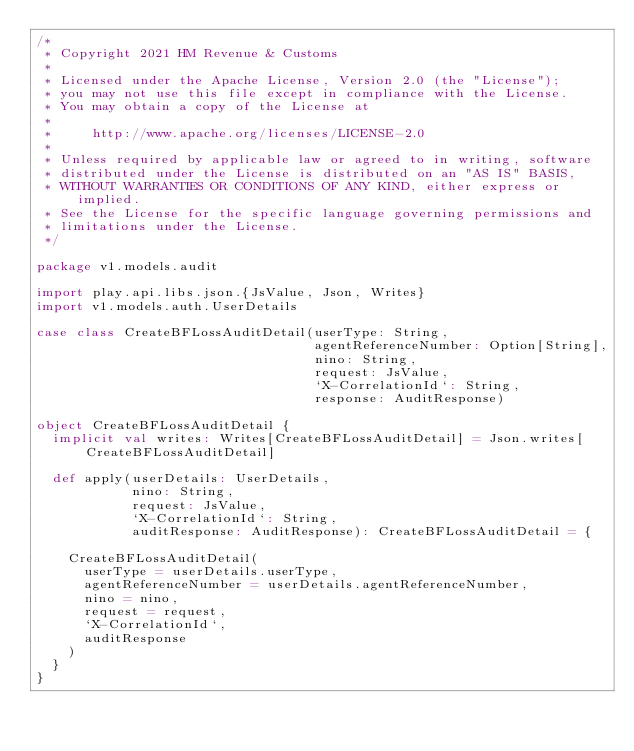Convert code to text. <code><loc_0><loc_0><loc_500><loc_500><_Scala_>/*
 * Copyright 2021 HM Revenue & Customs
 *
 * Licensed under the Apache License, Version 2.0 (the "License");
 * you may not use this file except in compliance with the License.
 * You may obtain a copy of the License at
 *
 *     http://www.apache.org/licenses/LICENSE-2.0
 *
 * Unless required by applicable law or agreed to in writing, software
 * distributed under the License is distributed on an "AS IS" BASIS,
 * WITHOUT WARRANTIES OR CONDITIONS OF ANY KIND, either express or implied.
 * See the License for the specific language governing permissions and
 * limitations under the License.
 */

package v1.models.audit

import play.api.libs.json.{JsValue, Json, Writes}
import v1.models.auth.UserDetails

case class CreateBFLossAuditDetail(userType: String,
                                   agentReferenceNumber: Option[String],
                                   nino: String,
                                   request: JsValue,
                                   `X-CorrelationId`: String,
                                   response: AuditResponse)

object CreateBFLossAuditDetail {
  implicit val writes: Writes[CreateBFLossAuditDetail] = Json.writes[CreateBFLossAuditDetail]

  def apply(userDetails: UserDetails,
            nino: String,
            request: JsValue,
            `X-CorrelationId`: String,
            auditResponse: AuditResponse): CreateBFLossAuditDetail = {

    CreateBFLossAuditDetail(
      userType = userDetails.userType,
      agentReferenceNumber = userDetails.agentReferenceNumber,
      nino = nino,
      request = request,
      `X-CorrelationId`,
      auditResponse
    )
  }
}

</code> 